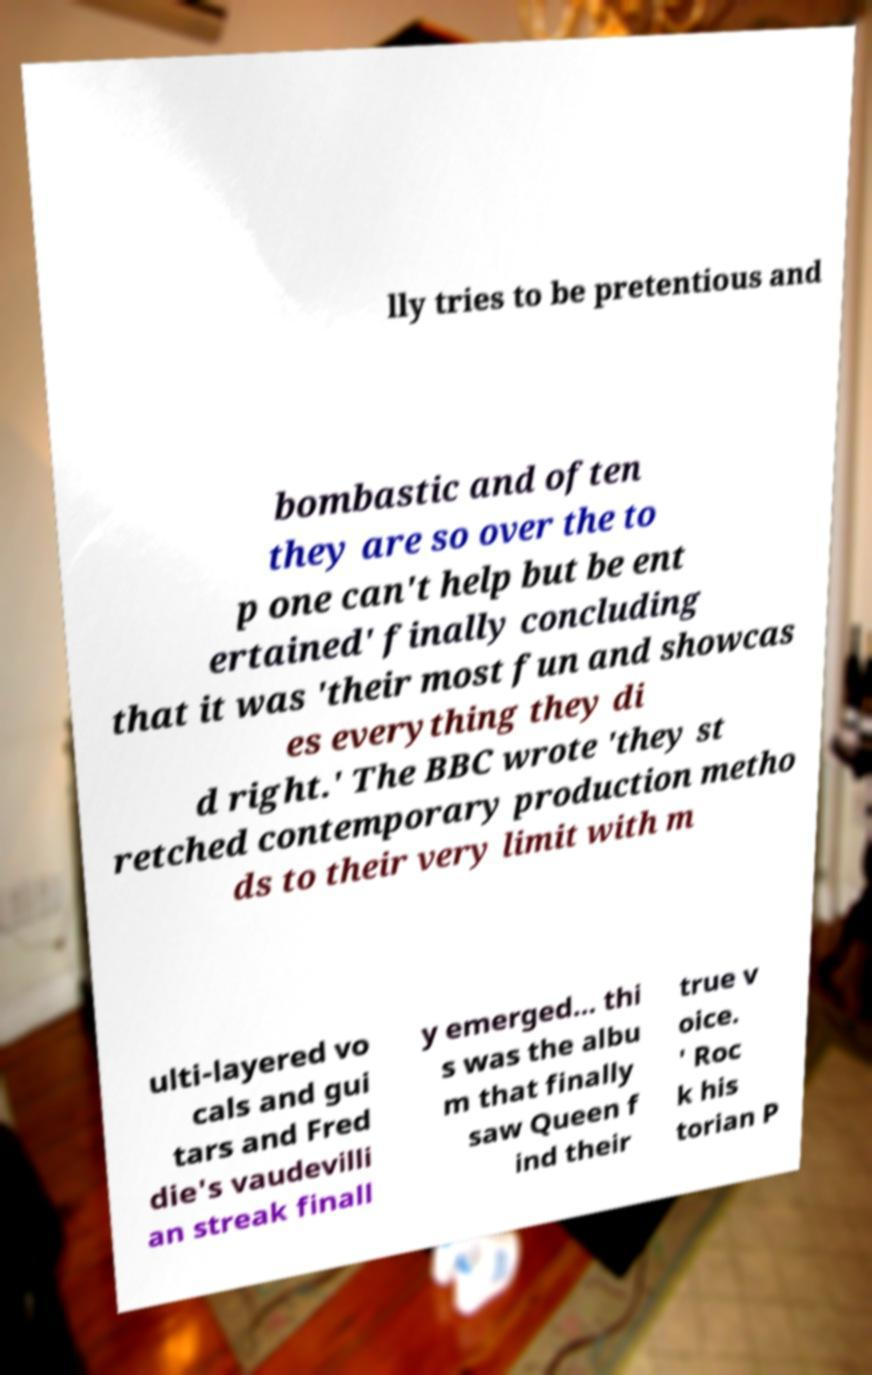Please identify and transcribe the text found in this image. lly tries to be pretentious and bombastic and often they are so over the to p one can't help but be ent ertained' finally concluding that it was 'their most fun and showcas es everything they di d right.' The BBC wrote 'they st retched contemporary production metho ds to their very limit with m ulti-layered vo cals and gui tars and Fred die's vaudevilli an streak finall y emerged... thi s was the albu m that finally saw Queen f ind their true v oice. ' Roc k his torian P 